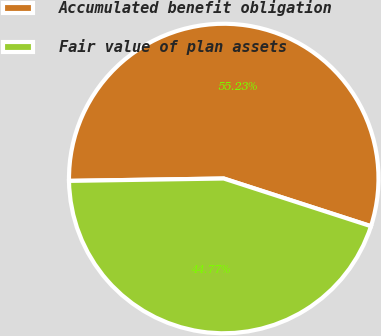Convert chart to OTSL. <chart><loc_0><loc_0><loc_500><loc_500><pie_chart><fcel>Accumulated benefit obligation<fcel>Fair value of plan assets<nl><fcel>55.23%<fcel>44.77%<nl></chart> 